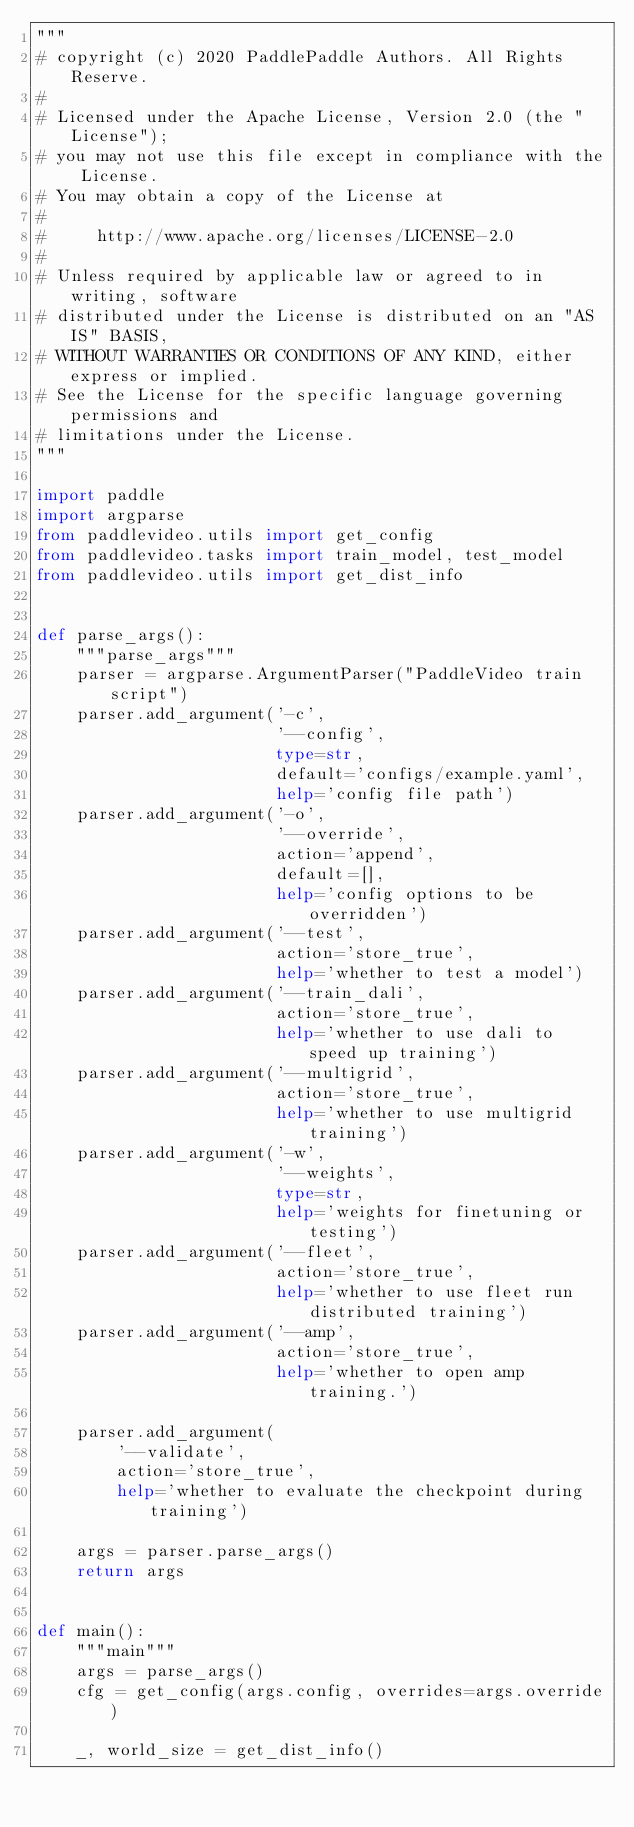Convert code to text. <code><loc_0><loc_0><loc_500><loc_500><_Python_>"""
# copyright (c) 2020 PaddlePaddle Authors. All Rights Reserve.
#
# Licensed under the Apache License, Version 2.0 (the "License");
# you may not use this file except in compliance with the License.
# You may obtain a copy of the License at
#
#     http://www.apache.org/licenses/LICENSE-2.0
#
# Unless required by applicable law or agreed to in writing, software
# distributed under the License is distributed on an "AS IS" BASIS,
# WITHOUT WARRANTIES OR CONDITIONS OF ANY KIND, either express or implied.
# See the License for the specific language governing permissions and
# limitations under the License.
"""

import paddle
import argparse
from paddlevideo.utils import get_config
from paddlevideo.tasks import train_model, test_model
from paddlevideo.utils import get_dist_info


def parse_args():
    """parse_args"""
    parser = argparse.ArgumentParser("PaddleVideo train script")
    parser.add_argument('-c',
                        '--config',
                        type=str,
                        default='configs/example.yaml',
                        help='config file path')
    parser.add_argument('-o',
                        '--override',
                        action='append',
                        default=[],
                        help='config options to be overridden')
    parser.add_argument('--test',
                        action='store_true',
                        help='whether to test a model')
    parser.add_argument('--train_dali',
                        action='store_true',
                        help='whether to use dali to speed up training')
    parser.add_argument('--multigrid',
                        action='store_true',
                        help='whether to use multigrid training')
    parser.add_argument('-w',
                        '--weights',
                        type=str,
                        help='weights for finetuning or testing')
    parser.add_argument('--fleet',
                        action='store_true',
                        help='whether to use fleet run distributed training')
    parser.add_argument('--amp',
                        action='store_true',
                        help='whether to open amp training.')

    parser.add_argument(
        '--validate',
        action='store_true',
        help='whether to evaluate the checkpoint during training')

    args = parser.parse_args()
    return args


def main():
    """main"""
    args = parse_args()
    cfg = get_config(args.config, overrides=args.override)

    _, world_size = get_dist_info()</code> 